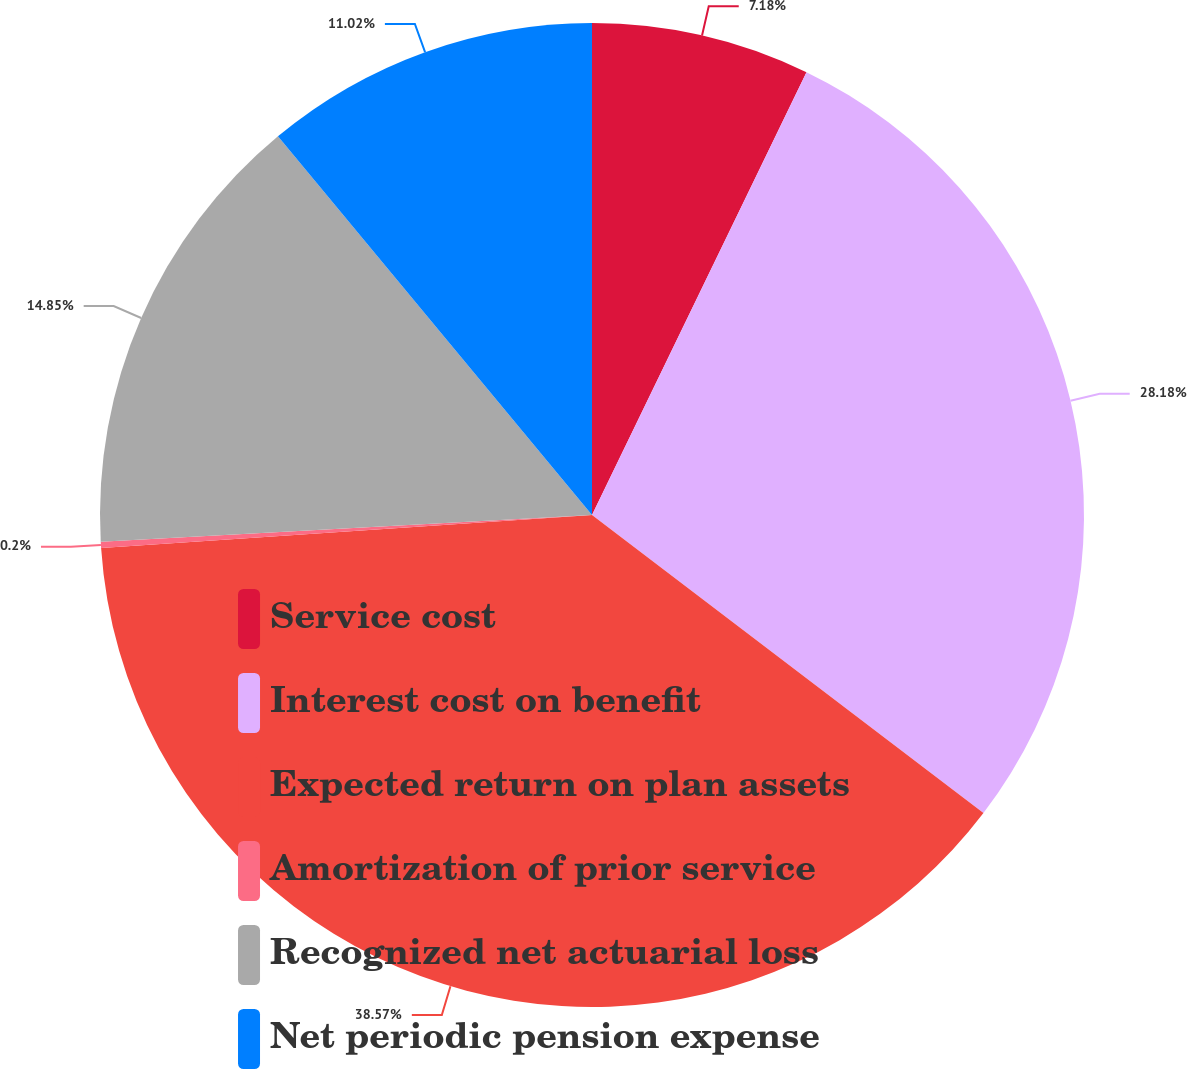Convert chart. <chart><loc_0><loc_0><loc_500><loc_500><pie_chart><fcel>Service cost<fcel>Interest cost on benefit<fcel>Expected return on plan assets<fcel>Amortization of prior service<fcel>Recognized net actuarial loss<fcel>Net periodic pension expense<nl><fcel>7.18%<fcel>28.18%<fcel>38.58%<fcel>0.2%<fcel>14.85%<fcel>11.02%<nl></chart> 